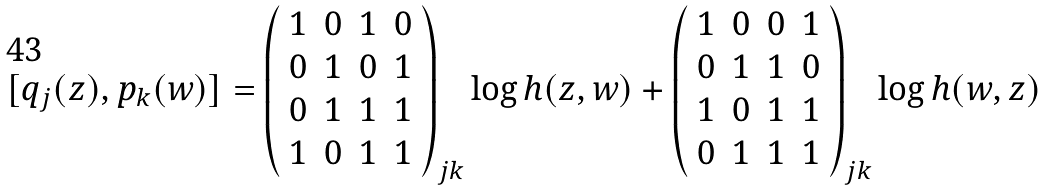<formula> <loc_0><loc_0><loc_500><loc_500>[ q _ { j } ( z ) , p _ { k } ( w ) ] = \left ( \begin{array} { c c c c } 1 & 0 & 1 & 0 \\ 0 & 1 & 0 & 1 \\ 0 & 1 & 1 & 1 \\ 1 & 0 & 1 & 1 \end{array} \right ) _ { j k } \log h ( z , w ) + \left ( \begin{array} { c c c c } 1 & 0 & 0 & 1 \\ 0 & 1 & 1 & 0 \\ 1 & 0 & 1 & 1 \\ 0 & 1 & 1 & 1 \end{array} \right ) _ { j k } \log h ( w , z )</formula> 